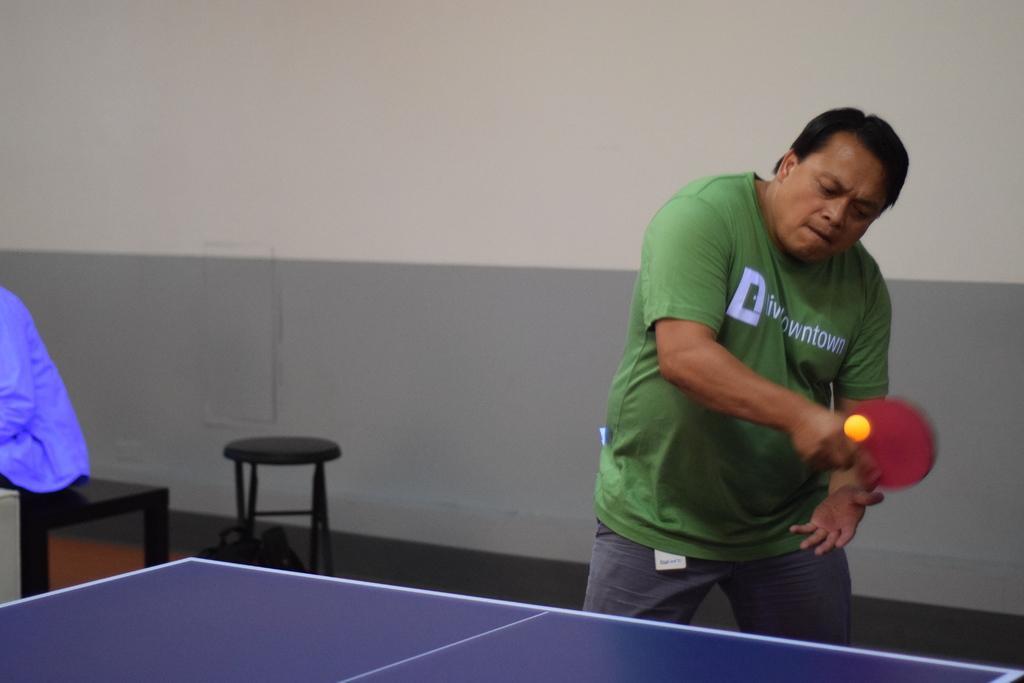Could you give a brief overview of what you see in this image? A man wearing a green t shirt is holding a table tennis bat. In front of him there is a table tennis table and ball is over there. In the background there is a stool and a wall. On the left a person sitting on a bench. 